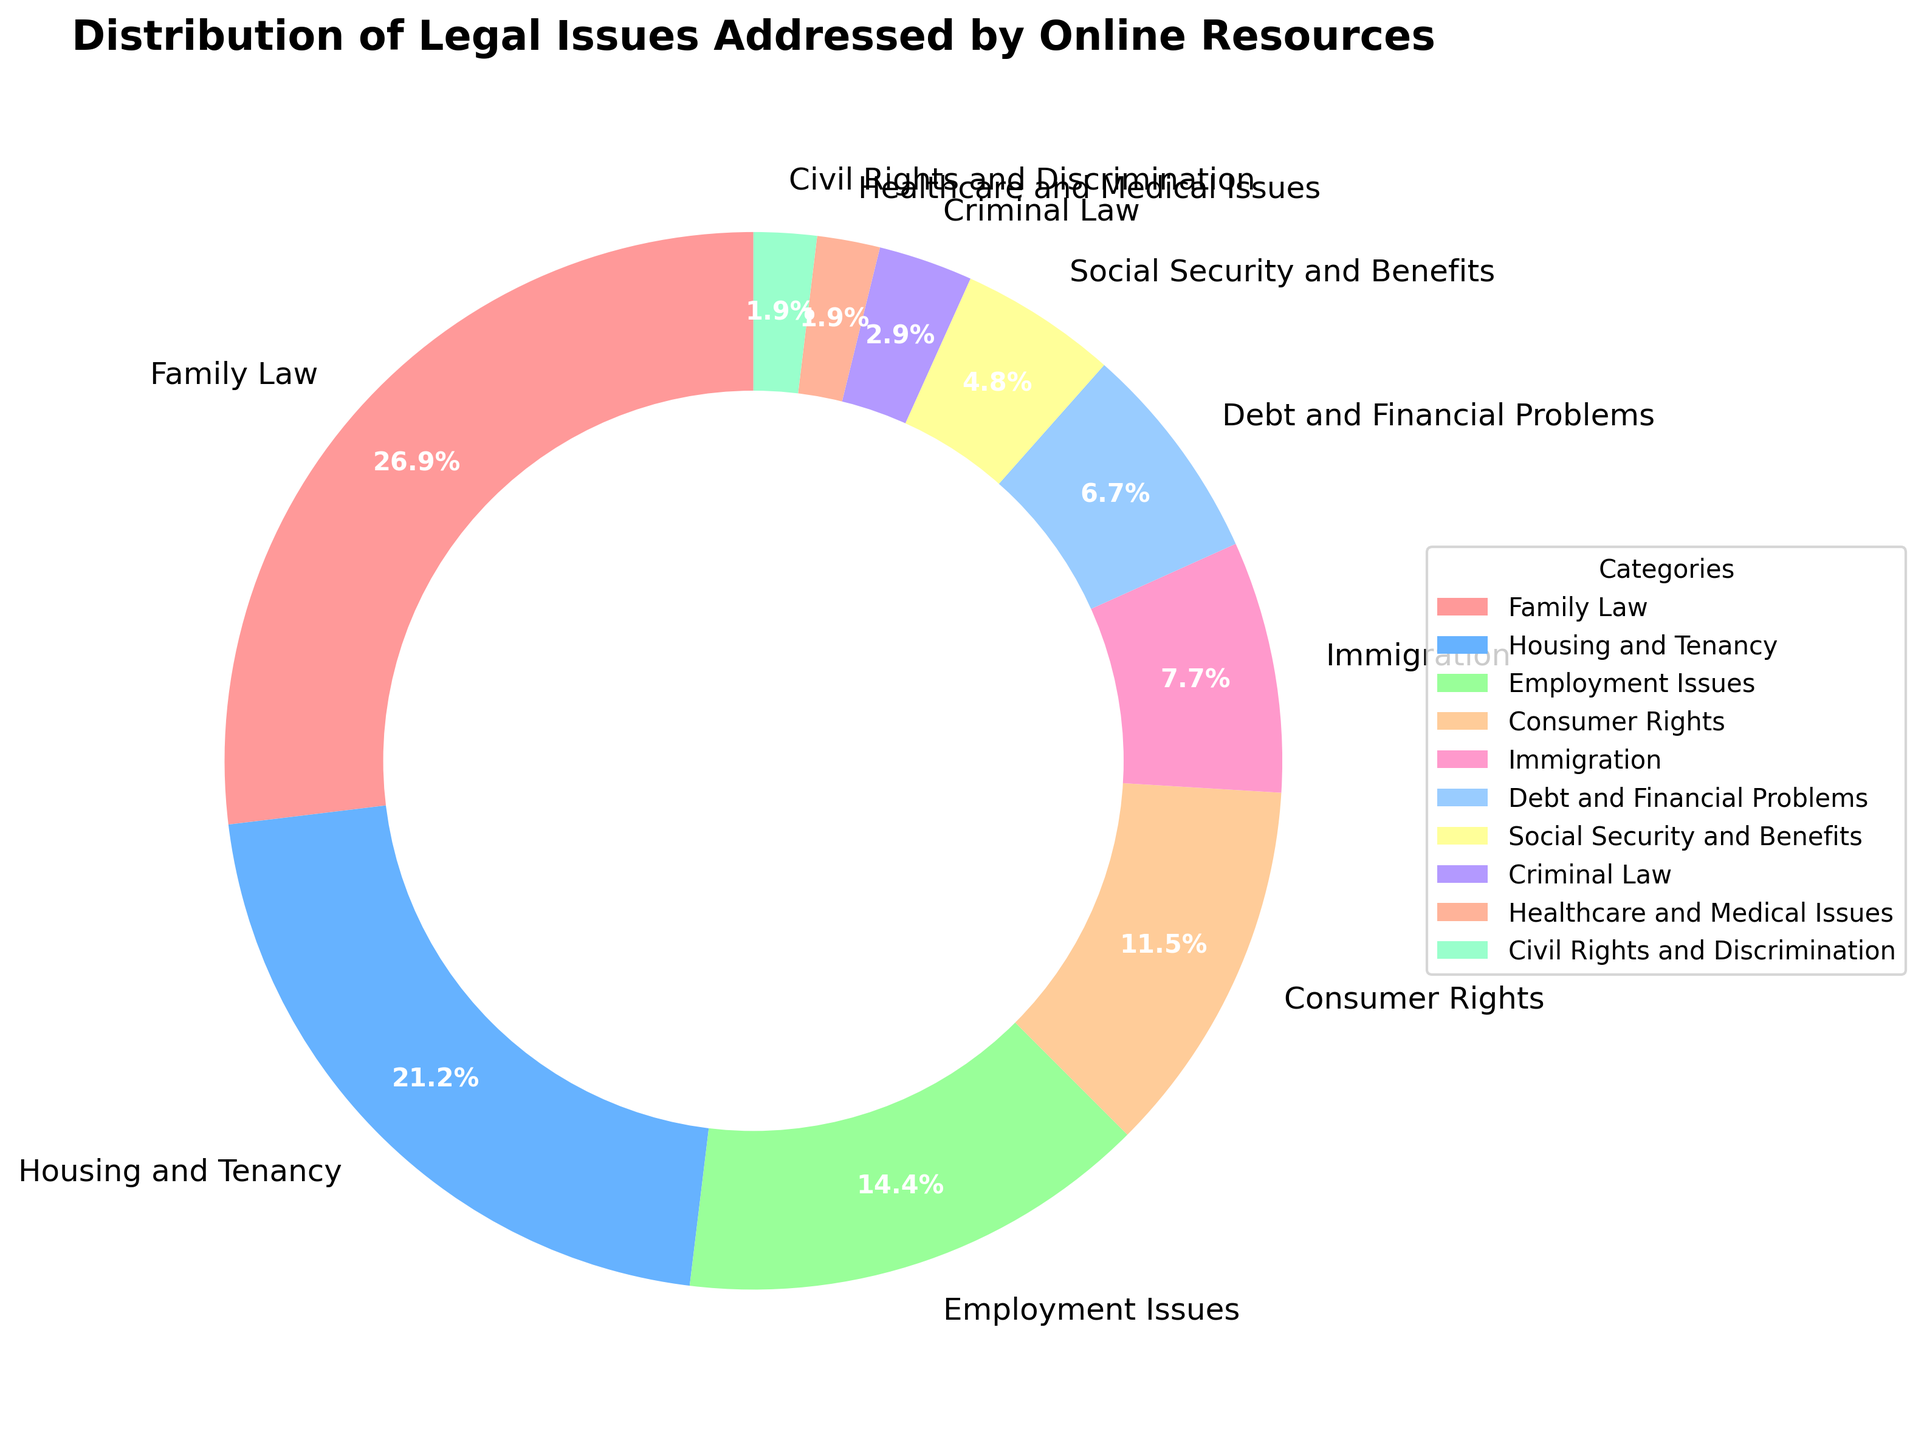What category addresses the highest percentage of legal issues? By looking at the pie chart, the segment labeled 'Family Law' appears to be the largest, indicating that it addresses the most significant share of legal issues.
Answer: Family Law What is the combined percentage of Family Law and Housing and Tenancy issues? The Family Law segment covers 28%, and the Housing and Tenancy segment covers 22%. By adding these percentages together, we find the combined coverage is 28% + 22% = 50%.
Answer: 50% Which category addresses fewer legal issues: Employment Issues or Consumer Rights? By comparing the sizes and labels of the pie chart segments, 'Employment Issues' covers 15% while 'Consumer Rights' covers 12%. Therefore, 'Consumer Rights' addresses fewer legal issues.
Answer: Consumer Rights How much larger is the percentage of legal issues related to Family Law compared to Healthcare and Medical Issues? Family Law accounts for 28% and Healthcare and Medical Issues account for 2%. The difference is calculated as 28% - 2% = 26%.
Answer: 26% List the categories that each address less than 10% of legal issues. From the pie chart, the categories with less than 10% coverage are Immigration (8%), Debt and Financial Problems (7%), Social Security and Benefits (5%), Criminal Law (3%), Healthcare and Medical Issues (2%), and Civil Rights and Discrimination (2%).
Answer: Immigration, Debt and Financial Problems, Social Security and Benefits, Criminal Law, Healthcare and Medical Issues, Civil Rights and Discrimination What is the total percentage addressed by the three smallest categories? The three smallest categories are Healthcare and Medical Issues (2%), Civil Rights and Discrimination (2%), and Criminal Law (3%). Adding these percentages gives 2% + 2% + 3% = 7%.
Answer: 7% Compare and contrast the visual area of the segments for Debt and Financial Problems and Social Security and Benefits. Visually, the segment for Debt and Financial Problems appears larger. According to the chart labels, Debt and Financial Problems addresses 7% of issues, while Social Security and Benefits addresses 5%. Thus, the segment size difference aligns with the numeric difference.
Answer: Debt and Financial Problems is larger How many categories each address more than 20% of the legal issues? By examining the pie chart, we identify that only Family Law (28%) and Housing and Tenancy (22%) each address more than 20% of the legal issues.
Answer: 2 What is the percentage difference between Employment Issues and Debt and Financial Problems? Employment Issues cover 15%, while Debt and Financial Problems cover 7%. The difference is 15% - 7% = 8%.
Answer: 8% If the categories of Criminal Law and Healthcare and Medical Issues were combined into one, what would the new segment’s percentage be? Criminal Law covers 3%, and Healthcare and Medical Issues cover 2%. By combining these, we get 3% + 2% = 5%.
Answer: 5% 